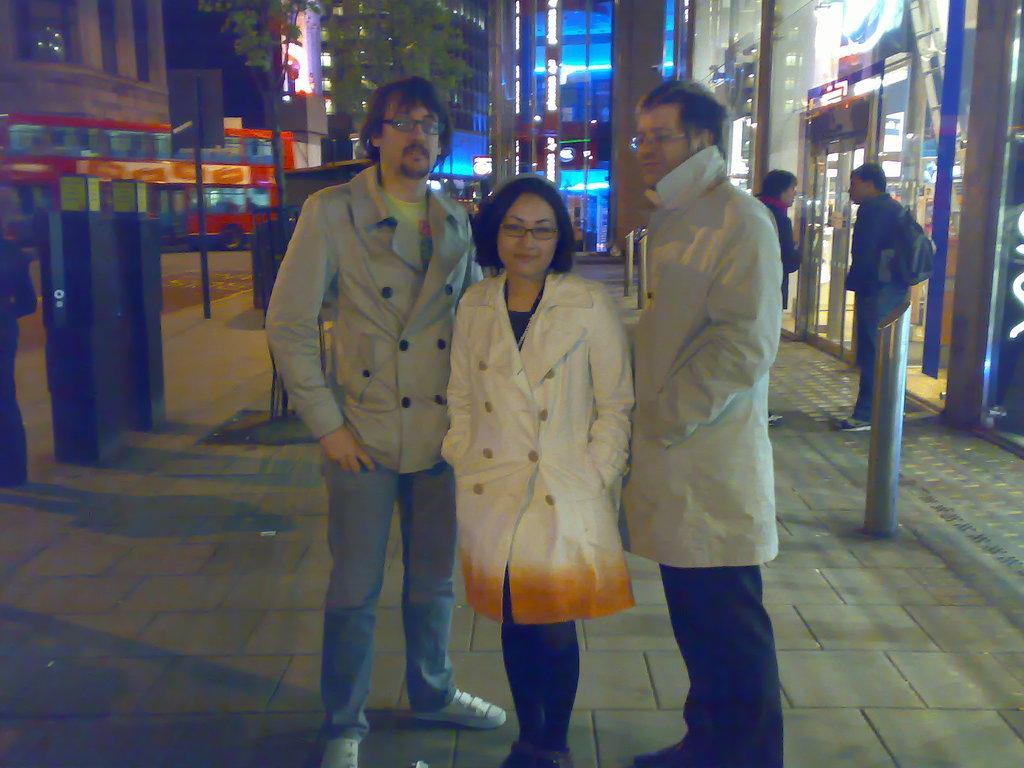How would you summarize this image in a sentence or two? In this image we can see a bus. There are many buildings and the stores in the image. There are few people are standing in the image. There are few objects on the footpath. 